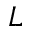<formula> <loc_0><loc_0><loc_500><loc_500>L</formula> 